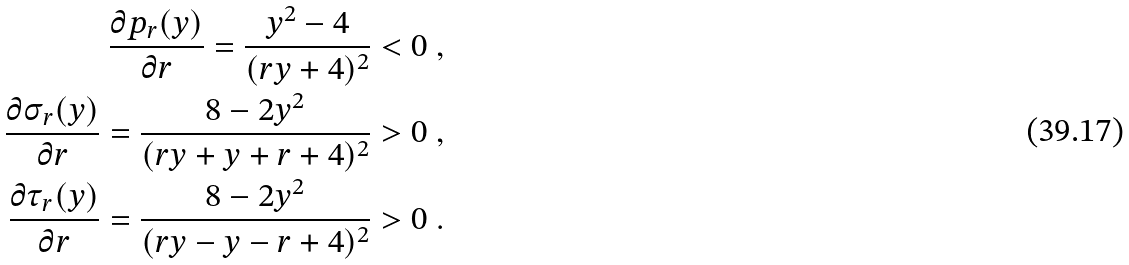Convert formula to latex. <formula><loc_0><loc_0><loc_500><loc_500>\frac { \partial p _ { r } ( y ) } { \partial r } = \frac { y ^ { 2 } - 4 } { ( r y + 4 ) ^ { 2 } } < 0 \ , \\ \frac { \partial \sigma _ { r } ( y ) } { \partial r } = \frac { 8 - 2 y ^ { 2 } } { ( r y + y + r + 4 ) ^ { 2 } } > 0 \ , \\ \frac { \partial \tau _ { r } ( y ) } { \partial r } = \frac { 8 - 2 y ^ { 2 } } { ( r y - y - r + 4 ) ^ { 2 } } > 0 \ .</formula> 